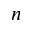<formula> <loc_0><loc_0><loc_500><loc_500>n</formula> 